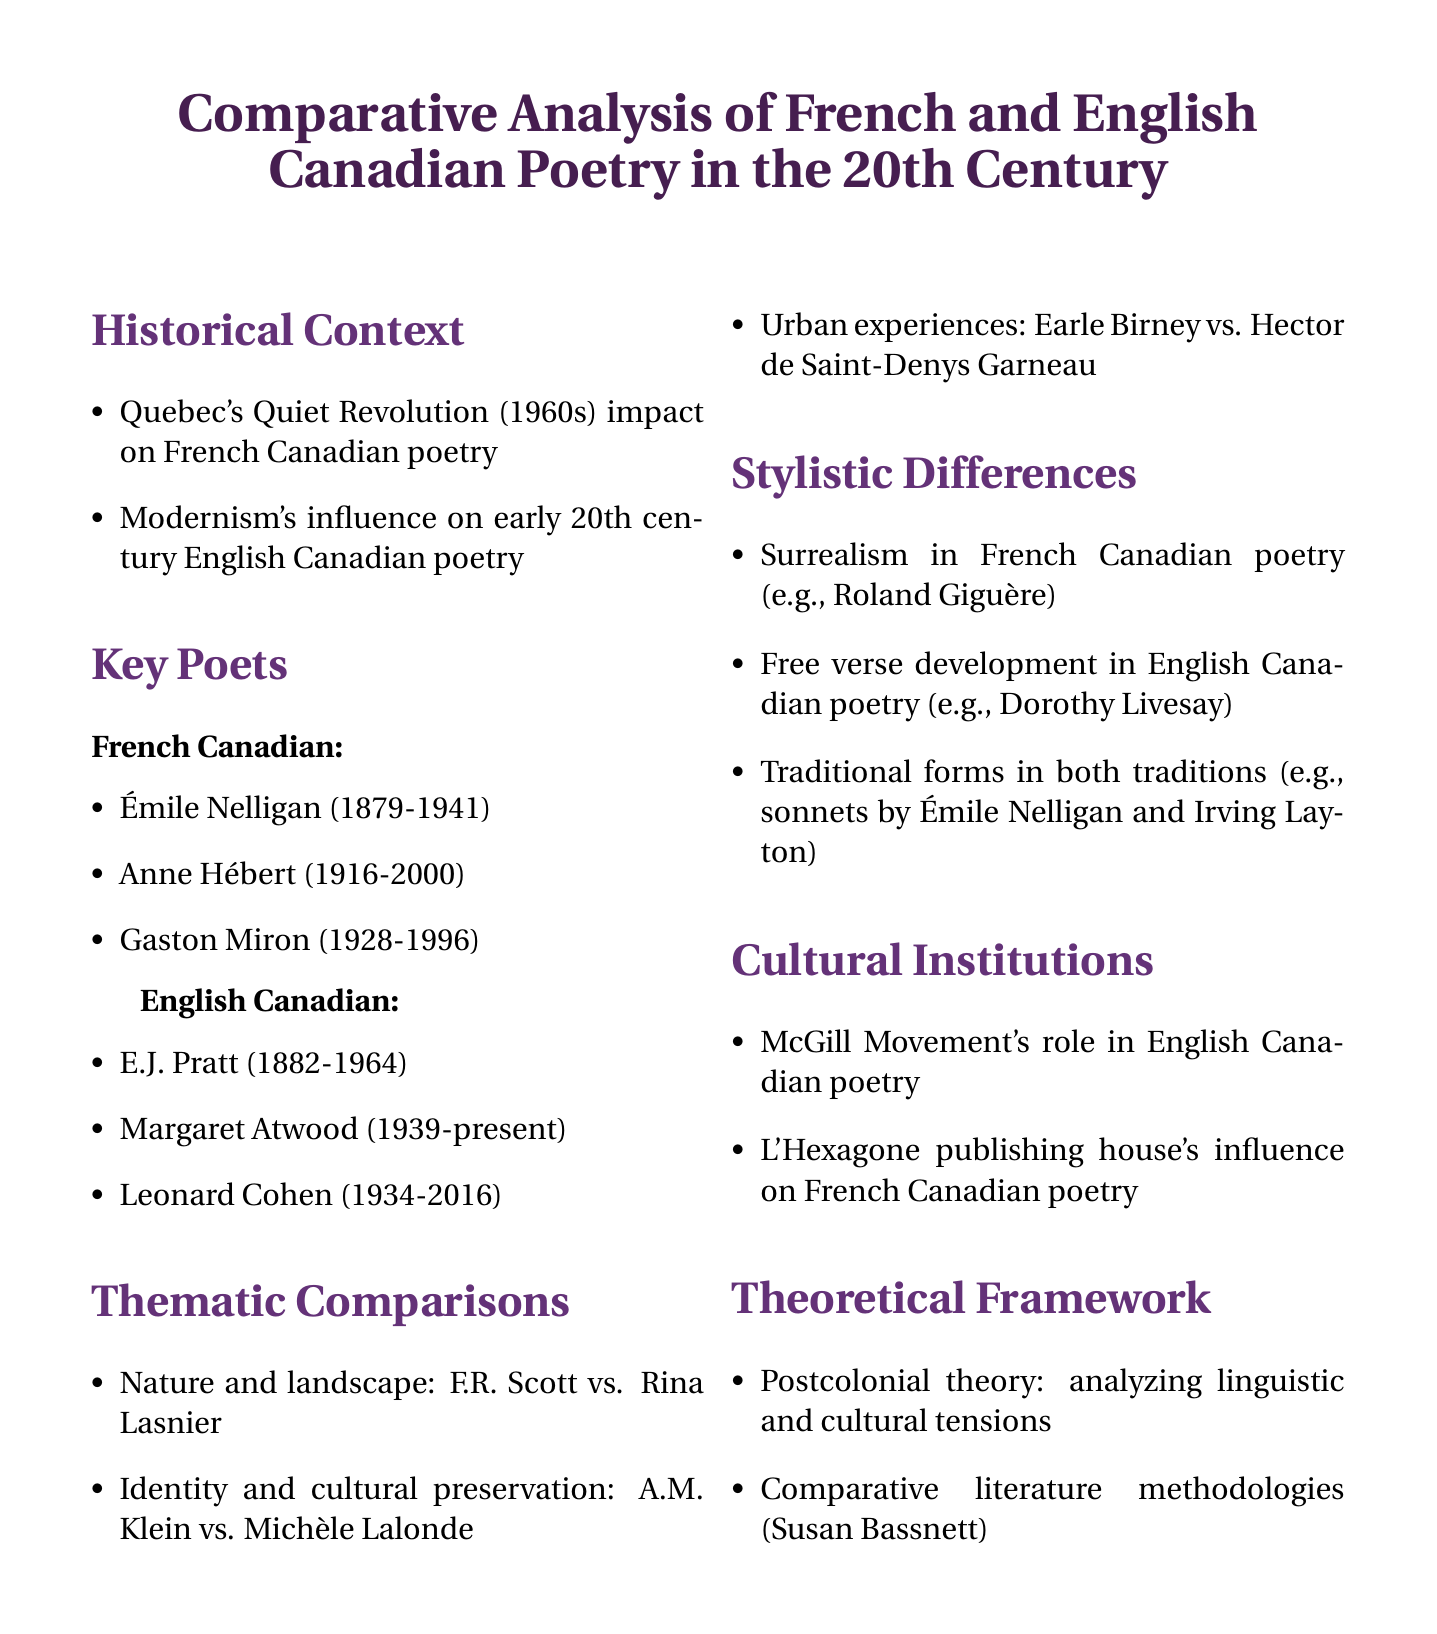What major event influenced French Canadian poetry in the 1960s? The document states that Quebec's Quiet Revolution had a significant impact on French Canadian poetry during the 1960s.
Answer: Quiet Revolution Who is a notable English Canadian poet born in 1939? The document lists Margaret Atwood as a prominent English Canadian poet born in 1939.
Answer: Margaret Atwood Which publishing house is mentioned as influencing French Canadian poetry? The document highlights the influence of L'Hexagone publishing house on French Canadian poetry.
Answer: L'Hexagone What is the primary theoretical framework suggested for analyzing the poems? The document mentions the application of postcolonial theory to analyze linguistic and cultural tensions in poetry.
Answer: Postcolonial theory Name one poet associated with the Montreal-based McGill Movement. The document does not specify names associated with the McGill Movement but indicates its role in English Canadian poetry.
Answer: Not specified What are two themes compared between the poets? The document details thematic comparisons, notably nature and landscape, and identity and cultural preservation in the works of specific poets.
Answer: Nature and landscape, Identity and cultural preservation Which type of poetic form is noted for being utilized by both French and English poets? The document mentions traditional forms being used in both French and English Canadian poetry, with examples of sonnets.
Answer: Sonnets Which poet is linked to surrealism in French Canadian poetry? The document exemplifies the influence of surrealism on French Canadian poetry through the poet Roland Giguère.
Answer: Roland Giguère What concept does Susan Bassnett’s methodologies pertain to? The document refers to comparative literature methodologies as developed by Susan Bassnett for analyzing poetry.
Answer: Comparative literature methodologies 